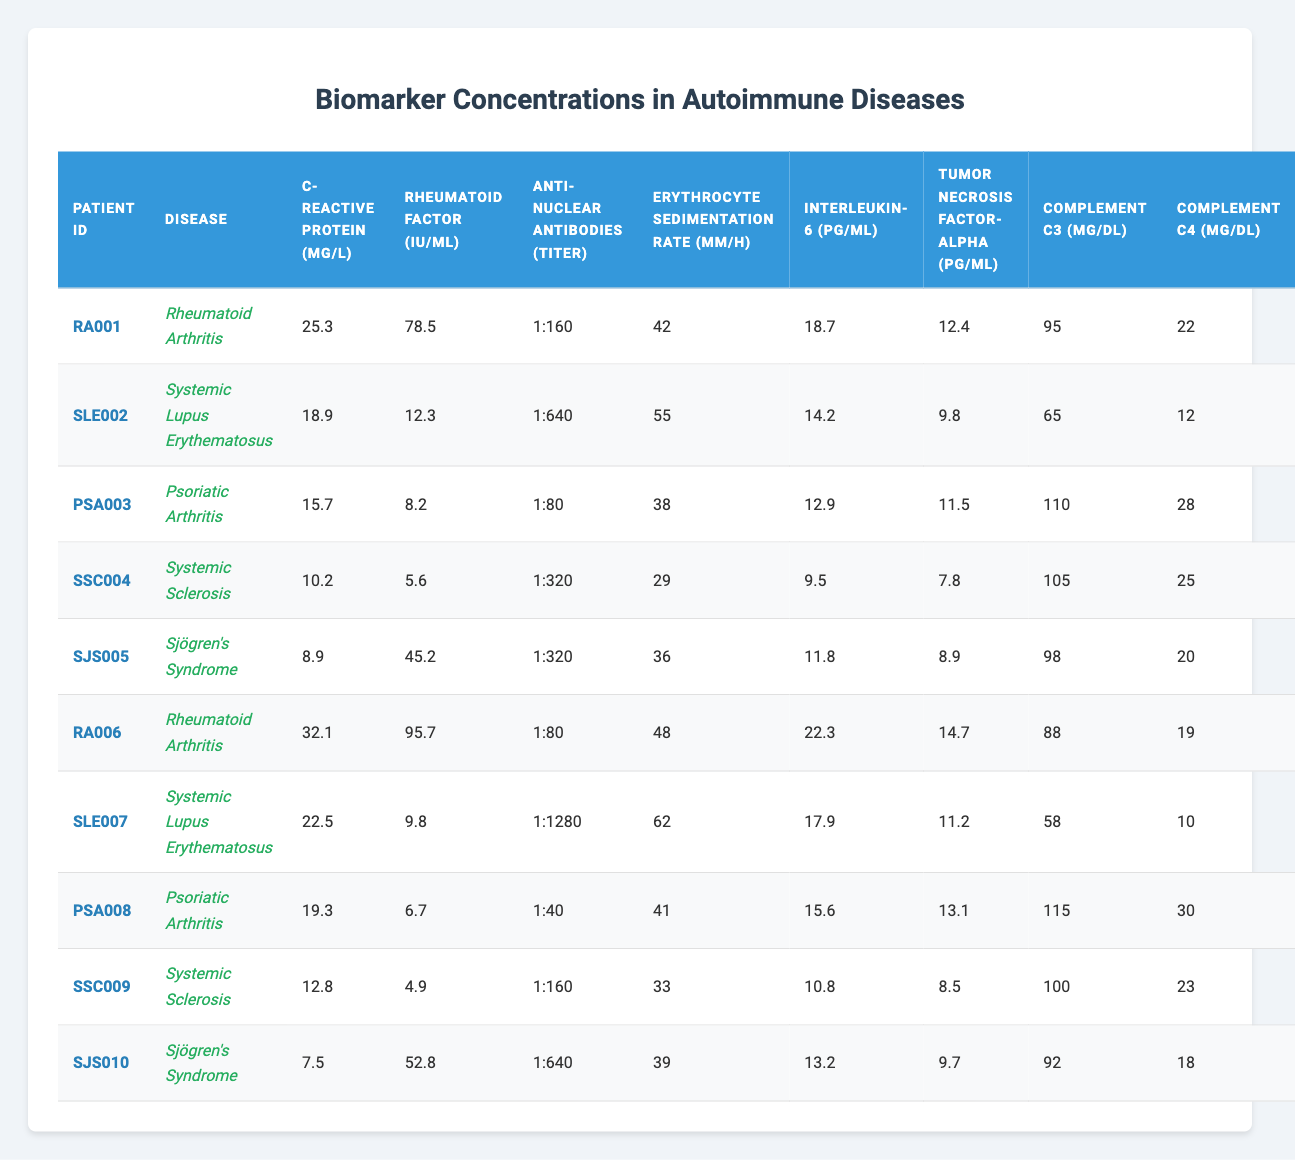What is the highest concentration of C-reactive protein among the patients? From the table, we see that the highest value of C-reactive protein is 32.1 mg/L corresponding to patient RA006 with Rheumatoid Arthritis.
Answer: 32.1 mg/L Which patient has the lowest level of Interleukin-6? Looking at the Interleukin-6 column, the lowest concentration is 7.5 pg/mL for patient SJS010 with Sjögren's Syndrome.
Answer: 7.5 pg/mL What is the mean Rheumatoid factor across all patients? To find the mean, we sum all the Rheumatoid factor values: (78.5 + 12.3 + 8.2 + 5.6 + 45.2 + 95.7 + 9.8 + 6.7 + 4.9 + 52.8) = 318.7 IU/mL. There are 10 patients, so the mean is 318.7 / 10 = 31.87 IU/mL.
Answer: 31.87 IU/mL Is the average Erythrocyte sedimentation rate greater than 40 mm/h? First, we calculate the total Erythrocyte sedimentation rates: (42 + 55 + 38 + 29 + 36 + 48 + 62 + 41 + 33 + 39) = 413 mm/h for 10 patients. The average is 413 / 10 = 41.3 mm/h, which is greater than 40 mm/h.
Answer: Yes Which disease has the highest average concentration of Tumor necrosis factor-alpha? We group the Tumor necrosis factor-alpha concentrations by disease: RA = (12.4 + 14.7) / 2 = 13.55 pg/mL, SLE = (14.2 + 11.2) / 2 = 12.7 pg/mL, PSA = (11.5 + 13.1) / 2 = 12.3 pg/mL, SSC = (7.8 + 8.5) / 2 = 8.15 pg/mL, SJS = (8.9 + 9.7) / 2 = 9.3 pg/mL. The highest average is for Rheumatoid Arthritis at 13.55 pg/mL.
Answer: Rheumatoid Arthritis How many patients have a complement C3 level greater than 100 mg/dL? We check the Complement C3 levels: RA001 (95), PSA003 (110), RA006 (88), PSA008 (115), SSC009 (100), SJS010 (92). Only PSA003 and PSA008 are greater than 100 mg/dL. Therefore, there are 2 patients.
Answer: 2 Are patients with Sjögren's Syndrome more likely to have lower C-reactive protein levels? Looking at the C-reactive protein values for Sjögren's Syndrome (8.9 mg/L and 7.5 mg/L) compared to those with other diseases (higher values), it indicates that Sjögren's patients present lower levels than others.
Answer: Yes What is the difference in Anti-nuclear antibodies titer between the highest and lowest values? The highest titer is 1:1280 from patient SLE007 and the lowest is 1:40 from patient PSA008. First, convert these titer ratios to numbers: 1280 - 40 = 1240 as the difference.
Answer: 1240 Which disease has the highest concentration of Interleukin-6? By checking the Interleukin-6 values, the highest is 22.3 pg/mL from patient RA006 diagnosed with Rheumatoid Arthritis, indicating it has the highest concentration in the table.
Answer: Rheumatoid Arthritis What is the total level of Complement C4 for all patients? Adding the Complement C4 values: (22 + 12 + 28 + 25 + 20 + 19 + 10 + 30 + 23 + 18) =  27.9 mg/dL total.
Answer: 27.9 mg/dL 